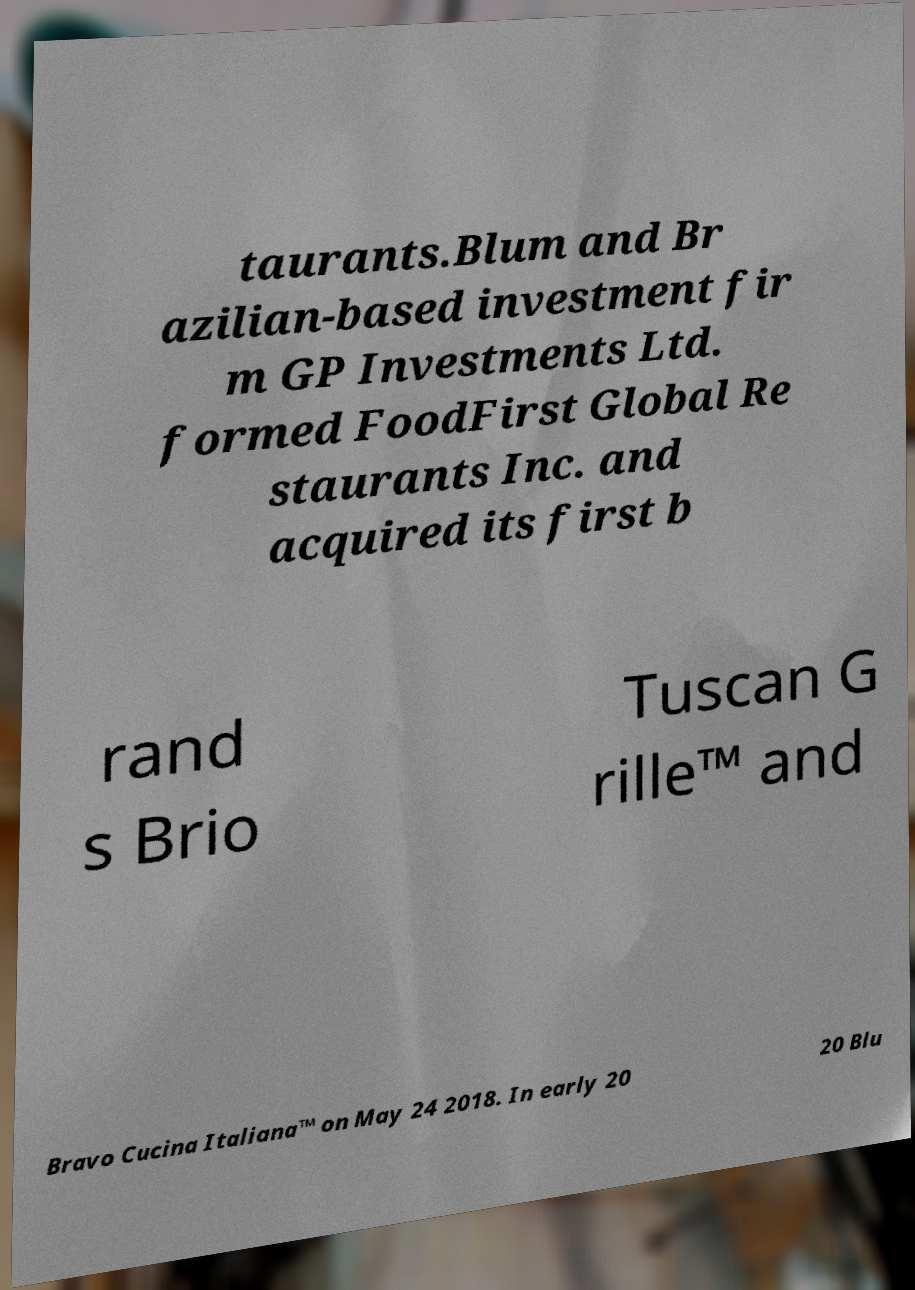I need the written content from this picture converted into text. Can you do that? taurants.Blum and Br azilian-based investment fir m GP Investments Ltd. formed FoodFirst Global Re staurants Inc. and acquired its first b rand s Brio Tuscan G rille™ and Bravo Cucina Italiana™ on May 24 2018. In early 20 20 Blu 